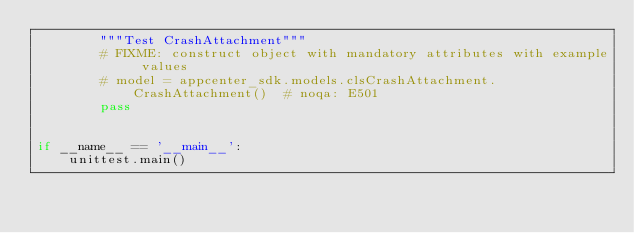Convert code to text. <code><loc_0><loc_0><loc_500><loc_500><_Python_>        """Test CrashAttachment"""
        # FIXME: construct object with mandatory attributes with example values
        # model = appcenter_sdk.models.clsCrashAttachment.CrashAttachment()  # noqa: E501
        pass


if __name__ == '__main__':
    unittest.main()
</code> 